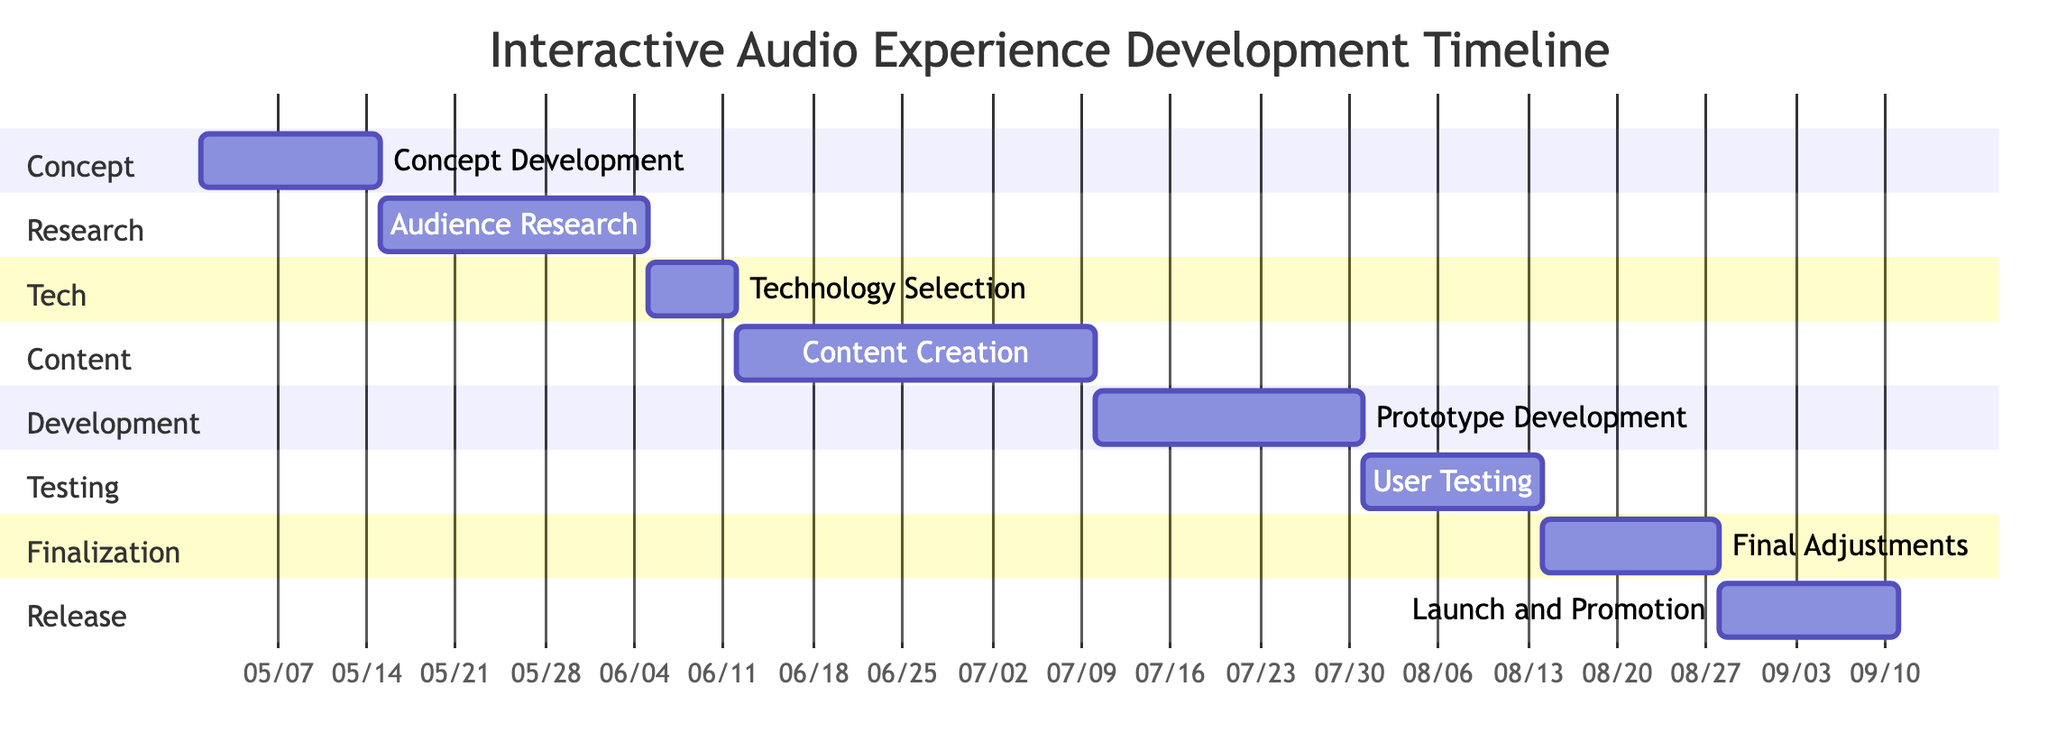What is the duration of the "User Testing" phase? The "User Testing" phase in the diagram shows a duration of 2 weeks. This information can be found directly beneath the name of the phase in the section labeled "Testing".
Answer: 2 weeks Which phase comes after "Content Creation"? The diagram illustrates that "Prototype Development" comes immediately after "Content Creation". This is determined by following the sequence of activities from the top section to the bottom.
Answer: Prototype Development How many weeks does the "Final Adjustments" phase last? The "Final Adjustments" phase lasts for 2 weeks, which is indicated next to the phase label in the "Finalization" section of the diagram.
Answer: 2 weeks What is the total number of phases displayed in the diagram? By counting the number of distinct phases listed in the diagram, there are a total of 8 phases presented throughout the Gantt chart sections.
Answer: 8 Which phase has the longest duration? The "Content Creation" phase has the longest duration of 4 weeks, which can be inferred by comparing the durations of all listed phases vertically in the diagram.
Answer: Content Creation What phase immediately precedes "Launch and Promotion"? In the diagram, "Final Adjustments" is the phase that immediately precedes "Launch and Promotion". This follows the sequential connection shown in the "Finalization" and "Release" sections of the Gantt chart.
Answer: Final Adjustments How many weeks are allocated for "Audience Research"? The "Audience Research" phase is allocated 3 weeks, as specified alongside the phase title in the diagram.
Answer: 3 weeks Which section contains the "Technology Selection" phase? The "Technology Selection" phase is located in the "Tech" section of the Gantt chart, as categorized by the headings established for each segment in the diagram.
Answer: Tech 